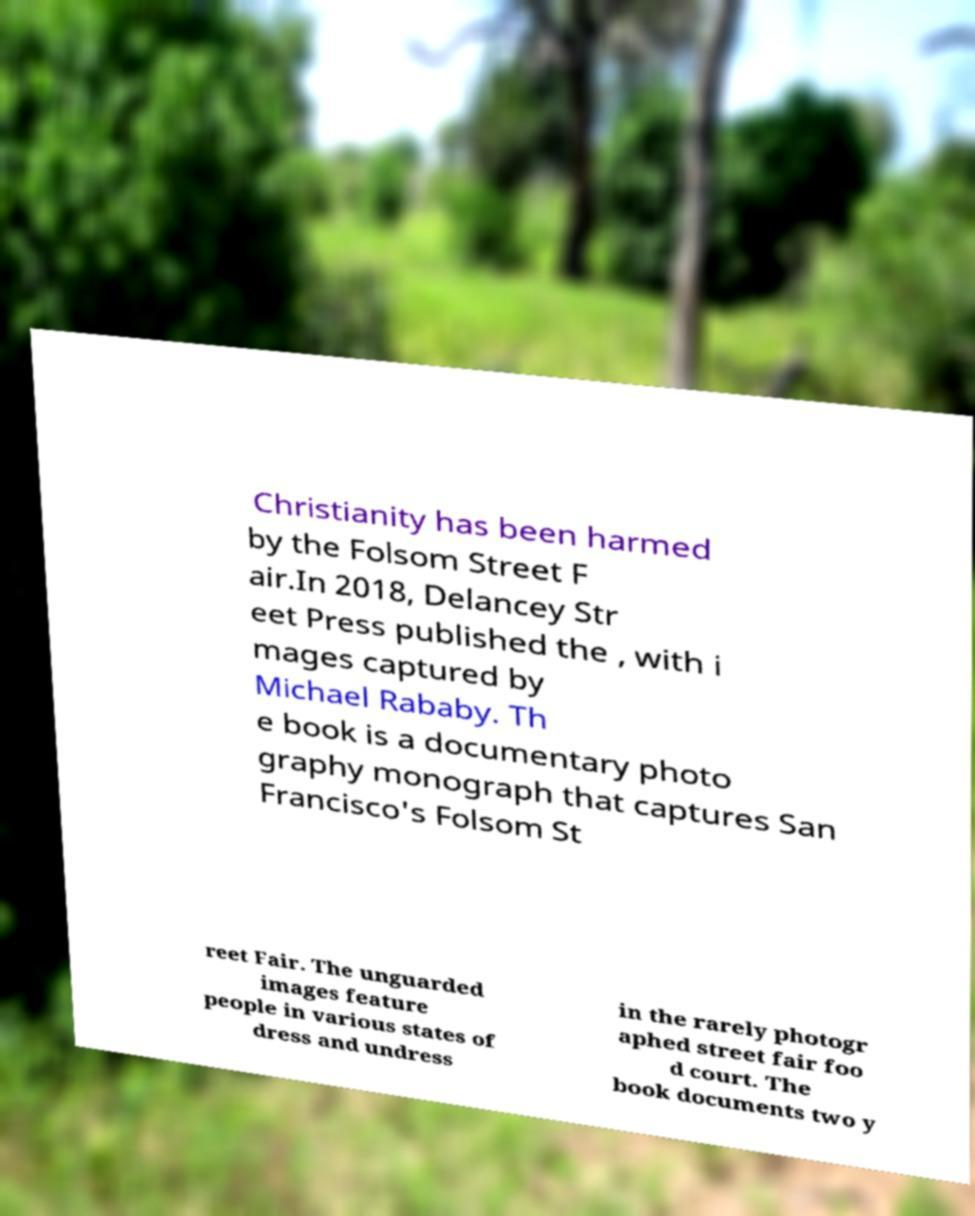Can you accurately transcribe the text from the provided image for me? Christianity has been harmed by the Folsom Street F air.In 2018, Delancey Str eet Press published the , with i mages captured by Michael Rababy. Th e book is a documentary photo graphy monograph that captures San Francisco's Folsom St reet Fair. The unguarded images feature people in various states of dress and undress in the rarely photogr aphed street fair foo d court. The book documents two y 